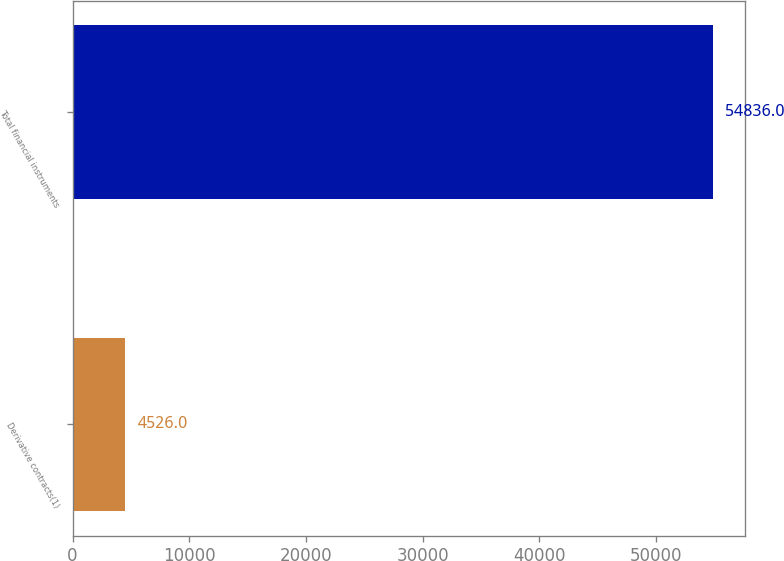Convert chart. <chart><loc_0><loc_0><loc_500><loc_500><bar_chart><fcel>Derivative contracts(1)<fcel>Total financial instruments<nl><fcel>4526<fcel>54836<nl></chart> 